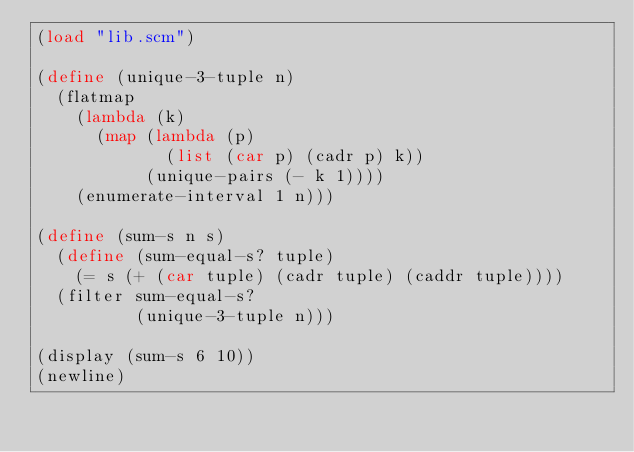Convert code to text. <code><loc_0><loc_0><loc_500><loc_500><_Scheme_>(load "lib.scm")

(define (unique-3-tuple n)
  (flatmap
    (lambda (k)
      (map (lambda (p)
             (list (car p) (cadr p) k))
           (unique-pairs (- k 1))))
    (enumerate-interval 1 n)))

(define (sum-s n s)
  (define (sum-equal-s? tuple)
    (= s (+ (car tuple) (cadr tuple) (caddr tuple))))
  (filter sum-equal-s?
          (unique-3-tuple n)))

(display (sum-s 6 10))
(newline)

</code> 